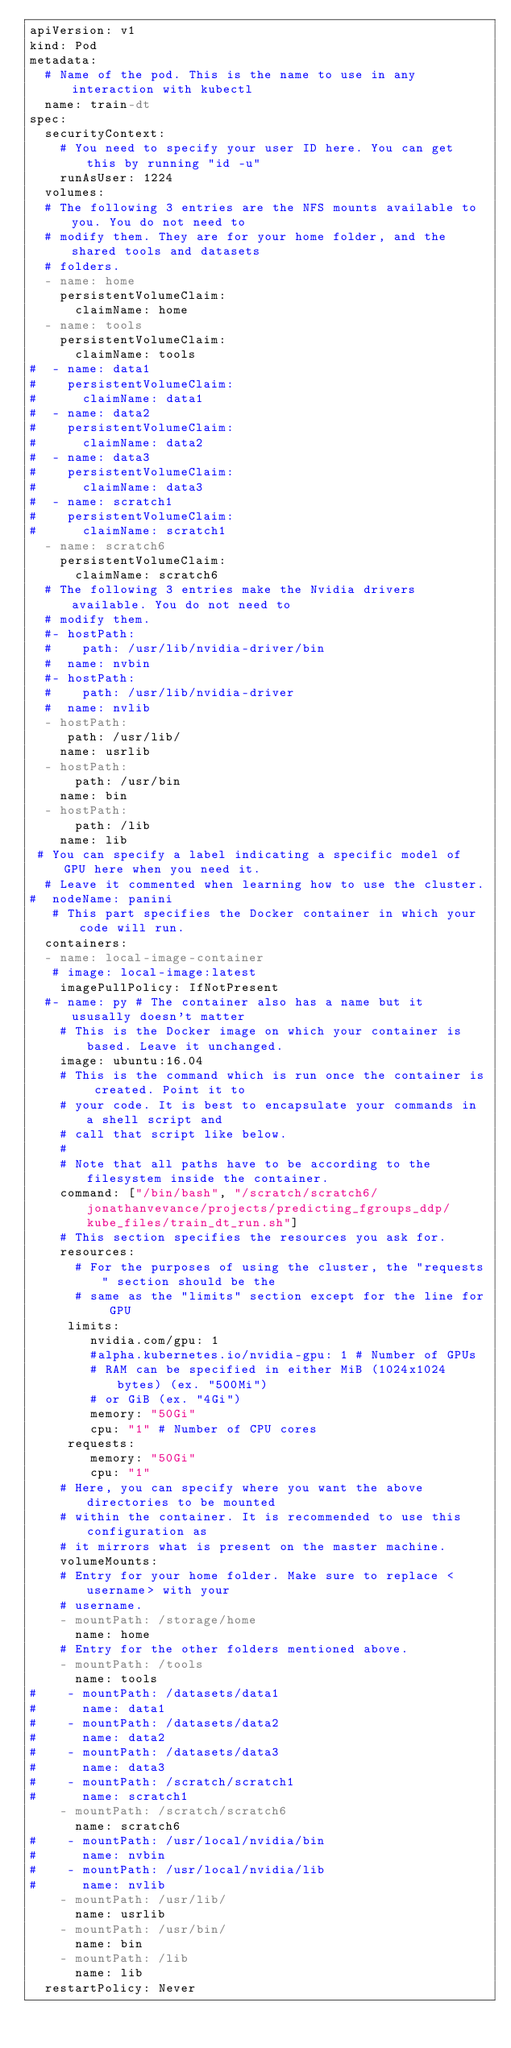<code> <loc_0><loc_0><loc_500><loc_500><_YAML_>apiVersion: v1
kind: Pod
metadata:
  # Name of the pod. This is the name to use in any interaction with kubectl
  name: train-dt
spec:
  securityContext:
    # You need to specify your user ID here. You can get this by running "id -u"
    runAsUser: 1224
  volumes:
  # The following 3 entries are the NFS mounts available to you. You do not need to
  # modify them. They are for your home folder, and the shared tools and datasets
  # folders.
  - name: home
    persistentVolumeClaim:
      claimName: home
  - name: tools
    persistentVolumeClaim:
      claimName: tools
#  - name: data1
#    persistentVolumeClaim:
#      claimName: data1
#  - name: data2
#    persistentVolumeClaim:
#      claimName: data2
#  - name: data3
#    persistentVolumeClaim:
#      claimName: data3
#  - name: scratch1
#    persistentVolumeClaim:
#      claimName: scratch1
  - name: scratch6
    persistentVolumeClaim:
      claimName: scratch6
  # The following 3 entries make the Nvidia drivers available. You do not need to
  # modify them.
  #- hostPath:
  #    path: /usr/lib/nvidia-driver/bin
  #  name: nvbin
  #- hostPath:
  #    path: /usr/lib/nvidia-driver
  #  name: nvlib
  - hostPath:
     path: /usr/lib/
    name: usrlib
  - hostPath:
      path: /usr/bin
    name: bin
  - hostPath:
      path: /lib
    name: lib
 # You can specify a label indicating a specific model of GPU here when you need it.
  # Leave it commented when learning how to use the cluster.
#  nodeName: panini
   # This part specifies the Docker container in which your code will run.
  containers:
  - name: local-image-container
   # image: local-image:latest
    imagePullPolicy: IfNotPresent
  #- name: py # The container also has a name but it ususally doesn't matter
    # This is the Docker image on which your container is based. Leave it unchanged.
    image: ubuntu:16.04
    # This is the command which is run once the container is created. Point it to
    # your code. It is best to encapsulate your commands in a shell script and
    # call that script like below.
    # 
    # Note that all paths have to be according to the filesystem inside the container.
    command: ["/bin/bash", "/scratch/scratch6/jonathanvevance/projects/predicting_fgroups_ddp/kube_files/train_dt_run.sh"]
    # This section specifies the resources you ask for.
    resources:
      # For the purposes of using the cluster, the "requests" section should be the
      # same as the "limits" section except for the line for GPU
     limits:
        nvidia.com/gpu: 1        
        #alpha.kubernetes.io/nvidia-gpu: 1 # Number of GPUs
        # RAM can be specified in either MiB (1024x1024 bytes) (ex. "500Mi")
        # or GiB (ex. "4Gi")
        memory: "50Gi"
        cpu: "1" # Number of CPU cores
     requests:
        memory: "50Gi"
        cpu: "1"
    # Here, you can specify where you want the above directories to be mounted
    # within the container. It is recommended to use this configuration as
    # it mirrors what is present on the master machine.
    volumeMounts:
    # Entry for your home folder. Make sure to replace <username> with your
    # username.
    - mountPath: /storage/home
      name: home
    # Entry for the other folders mentioned above.
    - mountPath: /tools
      name: tools
#    - mountPath: /datasets/data1
#      name: data1
#    - mountPath: /datasets/data2
#      name: data2
#    - mountPath: /datasets/data3
#      name: data3
#    - mountPath: /scratch/scratch1
#      name: scratch1
    - mountPath: /scratch/scratch6
      name: scratch6
#    - mountPath: /usr/local/nvidia/bin
#      name: nvbin
#    - mountPath: /usr/local/nvidia/lib
#      name: nvlib
    - mountPath: /usr/lib/
      name: usrlib
    - mountPath: /usr/bin/
      name: bin
    - mountPath: /lib
      name: lib
  restartPolicy: Never
</code> 